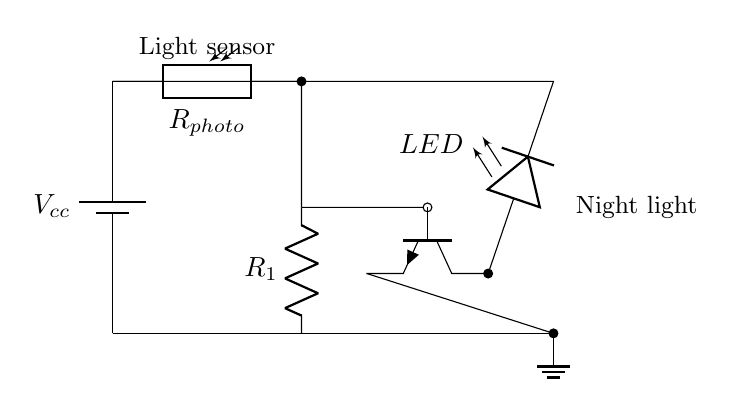What is the main function of the photoresistor in this circuit? The photoresistor's function is to change its resistance based on light intensity, which helps control the circuit. When it gets darker, the resistance increases, allowing the transistor to turn on the LED.
Answer: light sensor How many resistors are present in this circuit? There are two resistors in the circuit: the photoresistor and a separate resistor labeled R1.
Answer: two What happens to the LED when the room gets darker? When the room gets darker, the photoresistor allows the transistor to conduct more, powering the LED and making it light up.
Answer: LED lights up Which component is responsible for turning the LED on and off? The transistor acts as a switch that controls the LED based on the light received by the photoresistor. When the photoresistor detects low light, the transistor allows current to the LED.
Answer: transistor What type of LED is used in this circuit? The LED in this circuit is a standard light-emitting diode used for indication. It emits light when current passes through it.
Answer: LED Where does the ground connection go in this circuit? The ground connection is made at the bottom of the circuit, completing the circuit loop by connecting the lowest point to the ground reference, ensuring proper operation.
Answer: ground 